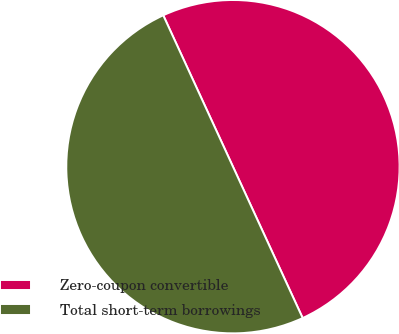Convert chart to OTSL. <chart><loc_0><loc_0><loc_500><loc_500><pie_chart><fcel>Zero-coupon convertible<fcel>Total short-term borrowings<nl><fcel>50.0%<fcel>50.0%<nl></chart> 